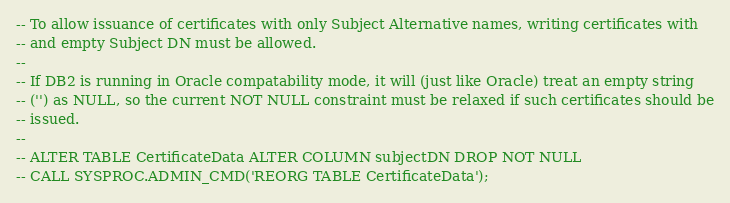<code> <loc_0><loc_0><loc_500><loc_500><_SQL_>-- To allow issuance of certificates with only Subject Alternative names, writing certificates with
-- and empty Subject DN must be allowed.
--
-- If DB2 is running in Oracle compatability mode, it will (just like Oracle) treat an empty string
-- ('') as NULL, so the current NOT NULL constraint must be relaxed if such certificates should be
-- issued.
--
-- ALTER TABLE CertificateData ALTER COLUMN subjectDN DROP NOT NULL
-- CALL SYSPROC.ADMIN_CMD('REORG TABLE CertificateData');
</code> 